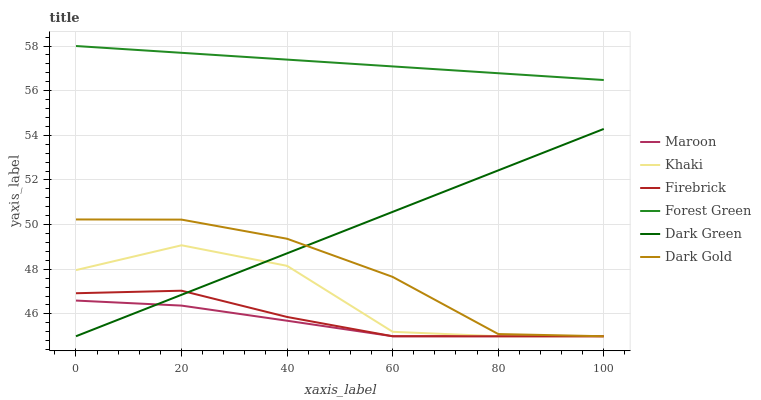Does Dark Gold have the minimum area under the curve?
Answer yes or no. No. Does Dark Gold have the maximum area under the curve?
Answer yes or no. No. Is Dark Gold the smoothest?
Answer yes or no. No. Is Dark Gold the roughest?
Answer yes or no. No. Does Forest Green have the lowest value?
Answer yes or no. No. Does Dark Gold have the highest value?
Answer yes or no. No. Is Maroon less than Forest Green?
Answer yes or no. Yes. Is Forest Green greater than Khaki?
Answer yes or no. Yes. Does Maroon intersect Forest Green?
Answer yes or no. No. 